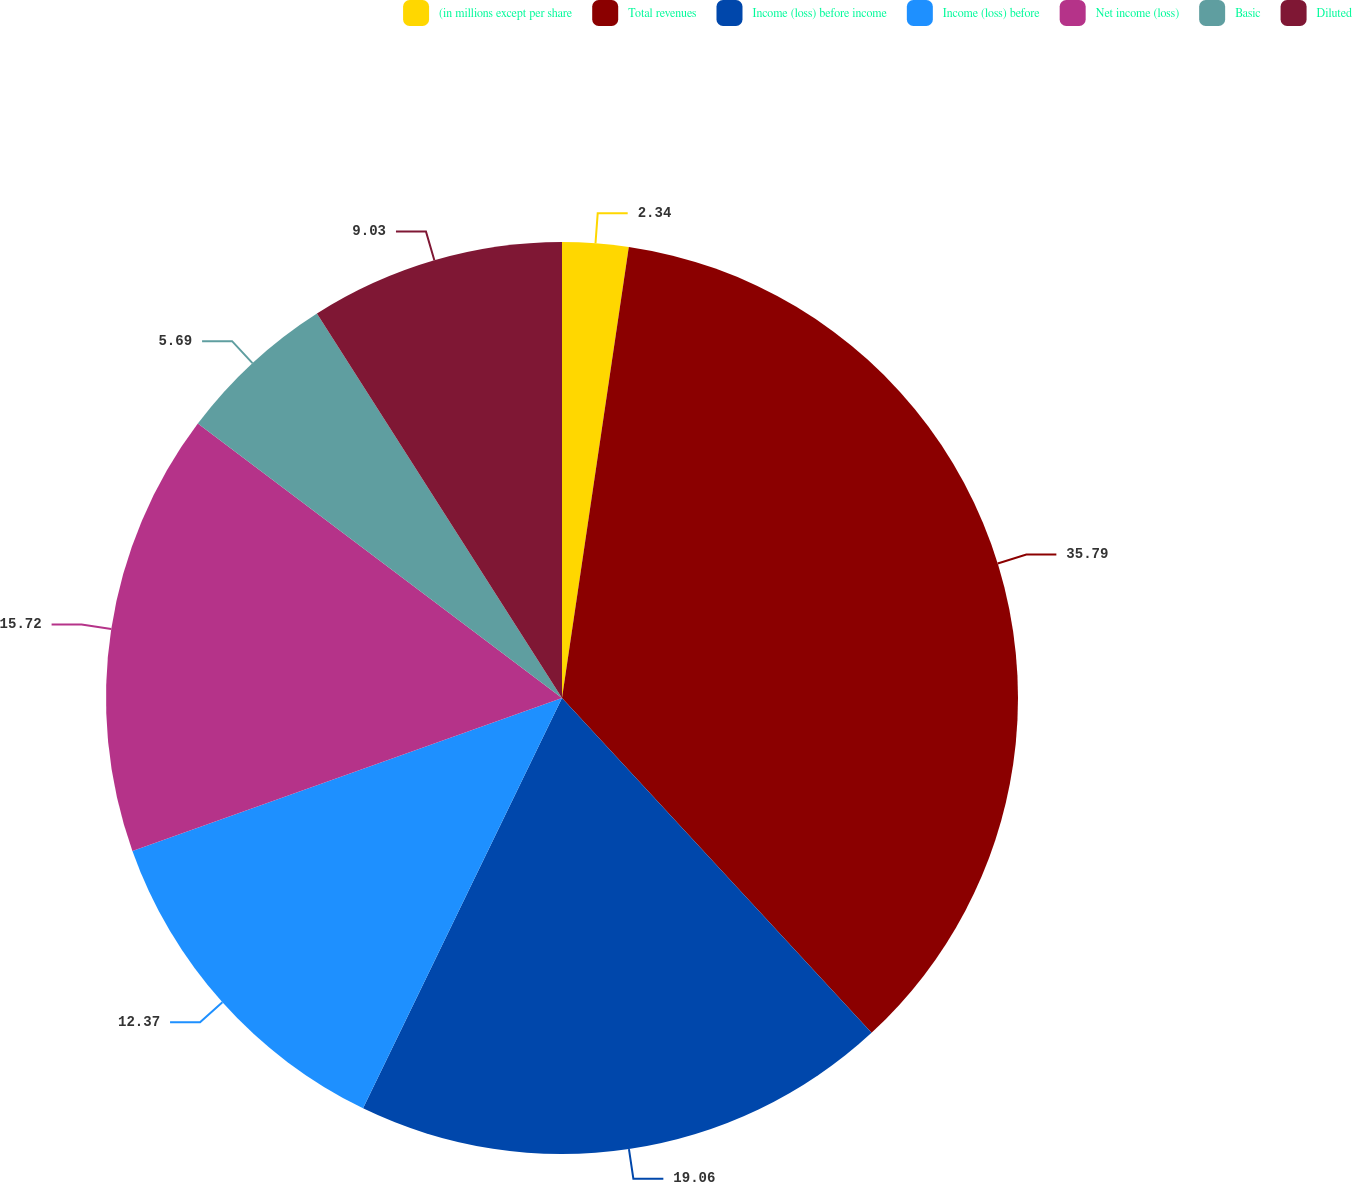Convert chart to OTSL. <chart><loc_0><loc_0><loc_500><loc_500><pie_chart><fcel>(in millions except per share<fcel>Total revenues<fcel>Income (loss) before income<fcel>Income (loss) before<fcel>Net income (loss)<fcel>Basic<fcel>Diluted<nl><fcel>2.34%<fcel>35.78%<fcel>19.06%<fcel>12.37%<fcel>15.72%<fcel>5.69%<fcel>9.03%<nl></chart> 